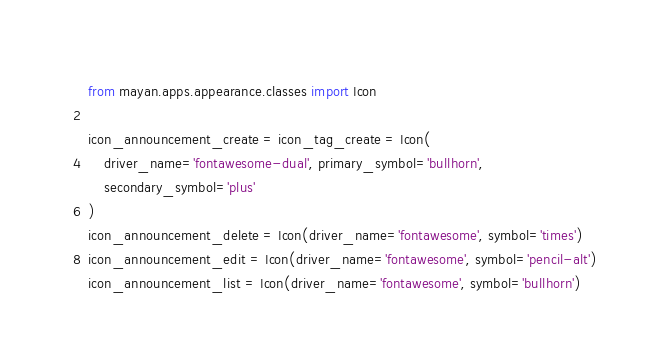Convert code to text. <code><loc_0><loc_0><loc_500><loc_500><_Python_>from mayan.apps.appearance.classes import Icon

icon_announcement_create = icon_tag_create = Icon(
    driver_name='fontawesome-dual', primary_symbol='bullhorn',
    secondary_symbol='plus'
)
icon_announcement_delete = Icon(driver_name='fontawesome', symbol='times')
icon_announcement_edit = Icon(driver_name='fontawesome', symbol='pencil-alt')
icon_announcement_list = Icon(driver_name='fontawesome', symbol='bullhorn')
</code> 